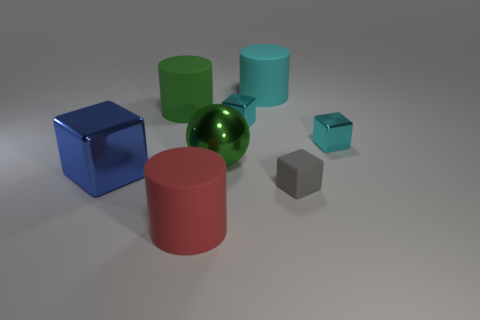Subtract all yellow cubes. Subtract all yellow cylinders. How many cubes are left? 4 Subtract all blue cubes. How many cyan spheres are left? 0 Add 4 tiny grays. How many reds exist? 0 Subtract all large blue metal cubes. Subtract all red rubber cylinders. How many objects are left? 6 Add 1 big shiny blocks. How many big shiny blocks are left? 2 Add 7 big green shiny things. How many big green shiny things exist? 8 Add 1 large blue cylinders. How many objects exist? 9 Subtract all green cylinders. How many cylinders are left? 2 Subtract all blue blocks. How many blocks are left? 3 Subtract 1 gray blocks. How many objects are left? 7 